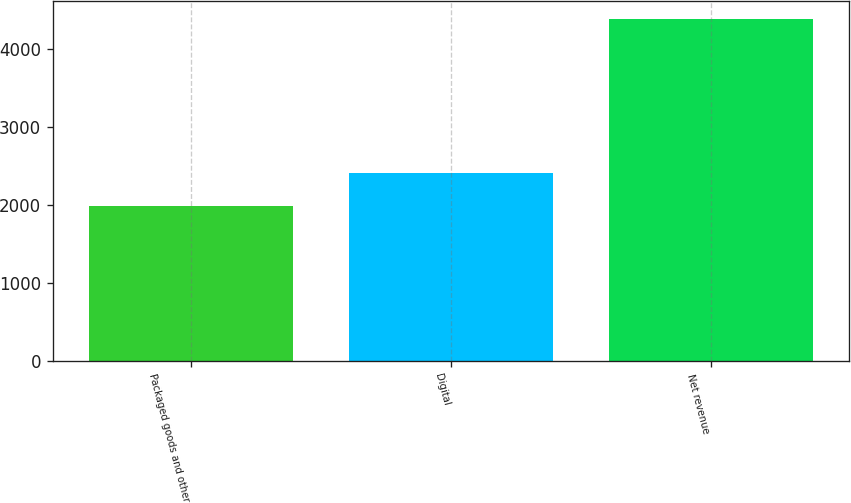<chart> <loc_0><loc_0><loc_500><loc_500><bar_chart><fcel>Packaged goods and other<fcel>Digital<fcel>Net revenue<nl><fcel>1987<fcel>2409<fcel>4396<nl></chart> 